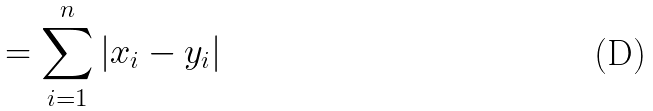<formula> <loc_0><loc_0><loc_500><loc_500>= \sum _ { i = 1 } ^ { n } | x _ { i } - y _ { i } |</formula> 